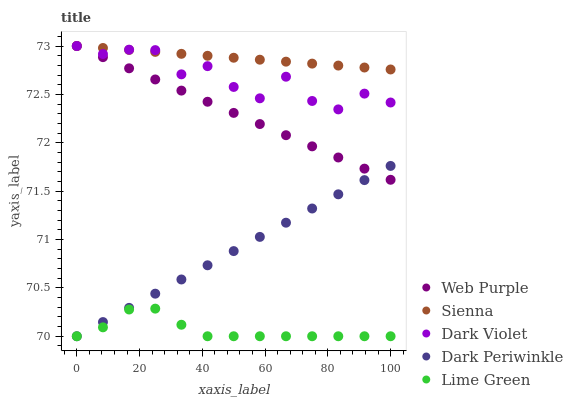Does Lime Green have the minimum area under the curve?
Answer yes or no. Yes. Does Sienna have the maximum area under the curve?
Answer yes or no. Yes. Does Web Purple have the minimum area under the curve?
Answer yes or no. No. Does Web Purple have the maximum area under the curve?
Answer yes or no. No. Is Sienna the smoothest?
Answer yes or no. Yes. Is Dark Violet the roughest?
Answer yes or no. Yes. Is Web Purple the smoothest?
Answer yes or no. No. Is Web Purple the roughest?
Answer yes or no. No. Does Lime Green have the lowest value?
Answer yes or no. Yes. Does Web Purple have the lowest value?
Answer yes or no. No. Does Dark Violet have the highest value?
Answer yes or no. Yes. Does Lime Green have the highest value?
Answer yes or no. No. Is Lime Green less than Dark Violet?
Answer yes or no. Yes. Is Web Purple greater than Lime Green?
Answer yes or no. Yes. Does Lime Green intersect Dark Periwinkle?
Answer yes or no. Yes. Is Lime Green less than Dark Periwinkle?
Answer yes or no. No. Is Lime Green greater than Dark Periwinkle?
Answer yes or no. No. Does Lime Green intersect Dark Violet?
Answer yes or no. No. 